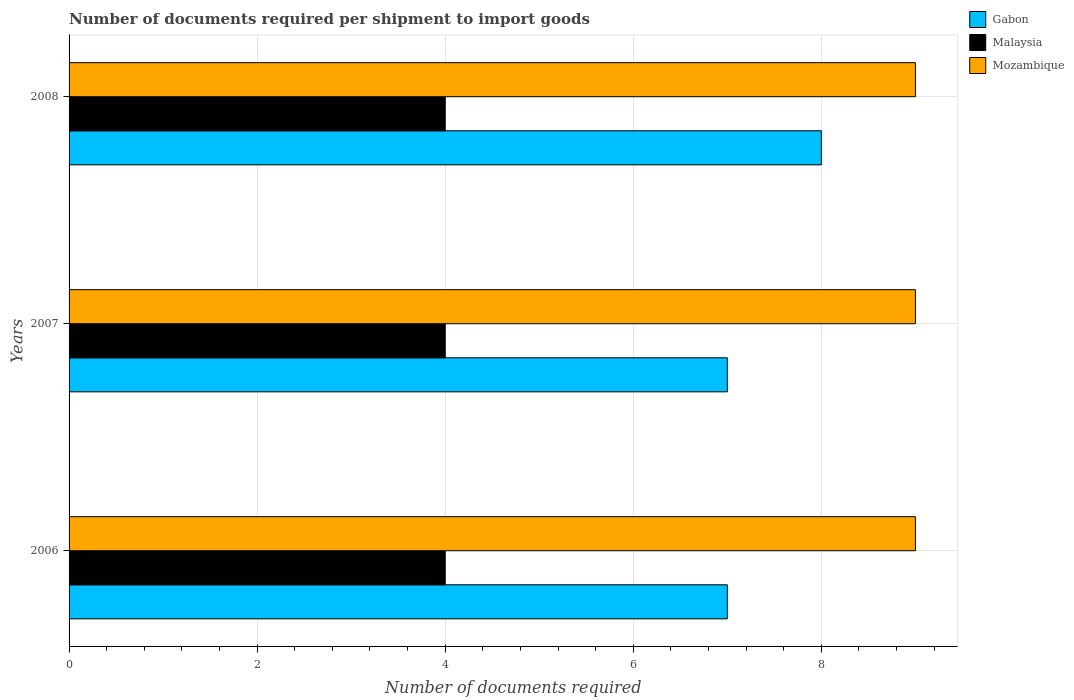In how many cases, is the number of bars for a given year not equal to the number of legend labels?
Your answer should be compact. 0. What is the number of documents required per shipment to import goods in Gabon in 2006?
Ensure brevity in your answer.  7. Across all years, what is the maximum number of documents required per shipment to import goods in Gabon?
Provide a succinct answer. 8. Across all years, what is the minimum number of documents required per shipment to import goods in Gabon?
Provide a succinct answer. 7. In which year was the number of documents required per shipment to import goods in Mozambique maximum?
Provide a succinct answer. 2006. In which year was the number of documents required per shipment to import goods in Malaysia minimum?
Offer a very short reply. 2006. What is the total number of documents required per shipment to import goods in Mozambique in the graph?
Your answer should be very brief. 27. What is the difference between the number of documents required per shipment to import goods in Malaysia in 2006 and the number of documents required per shipment to import goods in Gabon in 2007?
Your answer should be compact. -3. What is the average number of documents required per shipment to import goods in Gabon per year?
Your answer should be very brief. 7.33. In the year 2008, what is the difference between the number of documents required per shipment to import goods in Mozambique and number of documents required per shipment to import goods in Gabon?
Ensure brevity in your answer.  1. What is the ratio of the number of documents required per shipment to import goods in Gabon in 2007 to that in 2008?
Make the answer very short. 0.88. Is the number of documents required per shipment to import goods in Gabon in 2007 less than that in 2008?
Offer a terse response. Yes. What is the difference between the highest and the second highest number of documents required per shipment to import goods in Mozambique?
Ensure brevity in your answer.  0. What is the difference between the highest and the lowest number of documents required per shipment to import goods in Mozambique?
Ensure brevity in your answer.  0. In how many years, is the number of documents required per shipment to import goods in Malaysia greater than the average number of documents required per shipment to import goods in Malaysia taken over all years?
Ensure brevity in your answer.  0. What does the 2nd bar from the top in 2006 represents?
Provide a succinct answer. Malaysia. What does the 2nd bar from the bottom in 2007 represents?
Make the answer very short. Malaysia. Is it the case that in every year, the sum of the number of documents required per shipment to import goods in Gabon and number of documents required per shipment to import goods in Mozambique is greater than the number of documents required per shipment to import goods in Malaysia?
Your answer should be very brief. Yes. How many bars are there?
Your answer should be very brief. 9. Are all the bars in the graph horizontal?
Provide a succinct answer. Yes. How many years are there in the graph?
Your response must be concise. 3. What is the difference between two consecutive major ticks on the X-axis?
Give a very brief answer. 2. Are the values on the major ticks of X-axis written in scientific E-notation?
Give a very brief answer. No. Does the graph contain any zero values?
Ensure brevity in your answer.  No. Does the graph contain grids?
Your answer should be compact. Yes. Where does the legend appear in the graph?
Your response must be concise. Top right. How many legend labels are there?
Ensure brevity in your answer.  3. What is the title of the graph?
Make the answer very short. Number of documents required per shipment to import goods. Does "Argentina" appear as one of the legend labels in the graph?
Provide a succinct answer. No. What is the label or title of the X-axis?
Give a very brief answer. Number of documents required. What is the label or title of the Y-axis?
Give a very brief answer. Years. What is the Number of documents required of Gabon in 2006?
Your response must be concise. 7. What is the Number of documents required in Malaysia in 2006?
Provide a short and direct response. 4. What is the Number of documents required of Gabon in 2007?
Keep it short and to the point. 7. What is the Number of documents required of Malaysia in 2007?
Provide a succinct answer. 4. What is the Number of documents required of Malaysia in 2008?
Ensure brevity in your answer.  4. What is the Number of documents required in Mozambique in 2008?
Your answer should be very brief. 9. Across all years, what is the maximum Number of documents required in Gabon?
Provide a short and direct response. 8. Across all years, what is the maximum Number of documents required of Malaysia?
Offer a terse response. 4. Across all years, what is the minimum Number of documents required of Gabon?
Make the answer very short. 7. Across all years, what is the minimum Number of documents required in Malaysia?
Make the answer very short. 4. Across all years, what is the minimum Number of documents required of Mozambique?
Your answer should be very brief. 9. What is the total Number of documents required of Gabon in the graph?
Keep it short and to the point. 22. What is the total Number of documents required in Malaysia in the graph?
Keep it short and to the point. 12. What is the difference between the Number of documents required in Gabon in 2006 and that in 2007?
Offer a terse response. 0. What is the difference between the Number of documents required of Malaysia in 2006 and that in 2007?
Keep it short and to the point. 0. What is the difference between the Number of documents required in Gabon in 2006 and that in 2008?
Offer a very short reply. -1. What is the difference between the Number of documents required of Malaysia in 2006 and that in 2008?
Provide a succinct answer. 0. What is the difference between the Number of documents required of Mozambique in 2006 and that in 2008?
Your answer should be very brief. 0. What is the difference between the Number of documents required of Gabon in 2007 and that in 2008?
Provide a short and direct response. -1. What is the difference between the Number of documents required of Gabon in 2006 and the Number of documents required of Malaysia in 2007?
Keep it short and to the point. 3. What is the difference between the Number of documents required of Gabon in 2006 and the Number of documents required of Malaysia in 2008?
Your answer should be very brief. 3. What is the difference between the Number of documents required in Gabon in 2007 and the Number of documents required in Malaysia in 2008?
Offer a terse response. 3. What is the difference between the Number of documents required of Gabon in 2007 and the Number of documents required of Mozambique in 2008?
Make the answer very short. -2. What is the difference between the Number of documents required in Malaysia in 2007 and the Number of documents required in Mozambique in 2008?
Make the answer very short. -5. What is the average Number of documents required of Gabon per year?
Give a very brief answer. 7.33. In the year 2007, what is the difference between the Number of documents required of Gabon and Number of documents required of Mozambique?
Offer a terse response. -2. In the year 2008, what is the difference between the Number of documents required in Gabon and Number of documents required in Mozambique?
Your answer should be very brief. -1. In the year 2008, what is the difference between the Number of documents required of Malaysia and Number of documents required of Mozambique?
Make the answer very short. -5. What is the ratio of the Number of documents required in Gabon in 2006 to that in 2007?
Your answer should be very brief. 1. What is the ratio of the Number of documents required of Malaysia in 2006 to that in 2008?
Provide a short and direct response. 1. What is the ratio of the Number of documents required in Mozambique in 2006 to that in 2008?
Give a very brief answer. 1. What is the ratio of the Number of documents required in Gabon in 2007 to that in 2008?
Give a very brief answer. 0.88. What is the ratio of the Number of documents required in Malaysia in 2007 to that in 2008?
Your response must be concise. 1. What is the difference between the highest and the second highest Number of documents required in Gabon?
Ensure brevity in your answer.  1. What is the difference between the highest and the second highest Number of documents required of Malaysia?
Keep it short and to the point. 0. What is the difference between the highest and the second highest Number of documents required in Mozambique?
Your response must be concise. 0. What is the difference between the highest and the lowest Number of documents required in Gabon?
Your answer should be very brief. 1. What is the difference between the highest and the lowest Number of documents required of Malaysia?
Make the answer very short. 0. 